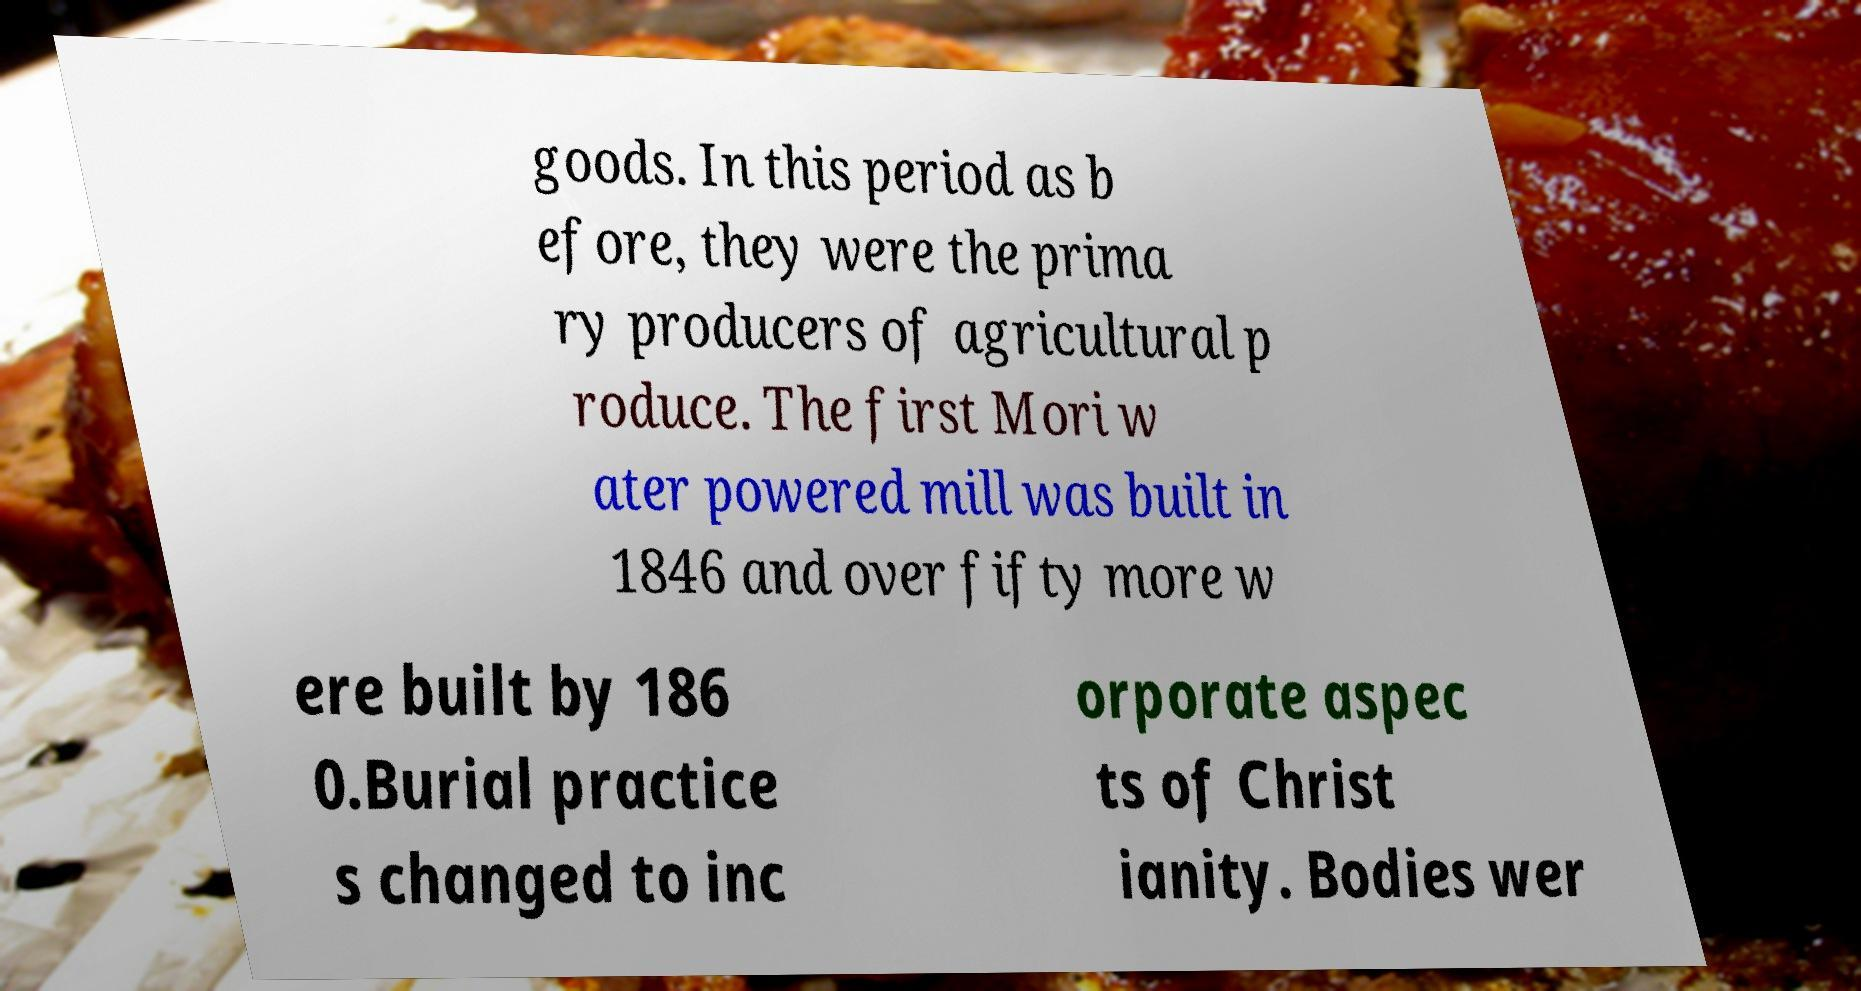What messages or text are displayed in this image? I need them in a readable, typed format. goods. In this period as b efore, they were the prima ry producers of agricultural p roduce. The first Mori w ater powered mill was built in 1846 and over fifty more w ere built by 186 0.Burial practice s changed to inc orporate aspec ts of Christ ianity. Bodies wer 